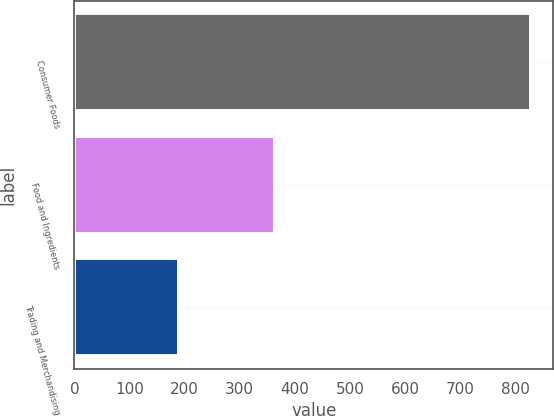<chart> <loc_0><loc_0><loc_500><loc_500><bar_chart><fcel>Consumer Foods<fcel>Food and Ingredients<fcel>Trading and Merchandising<nl><fcel>828<fcel>364<fcel>189<nl></chart> 